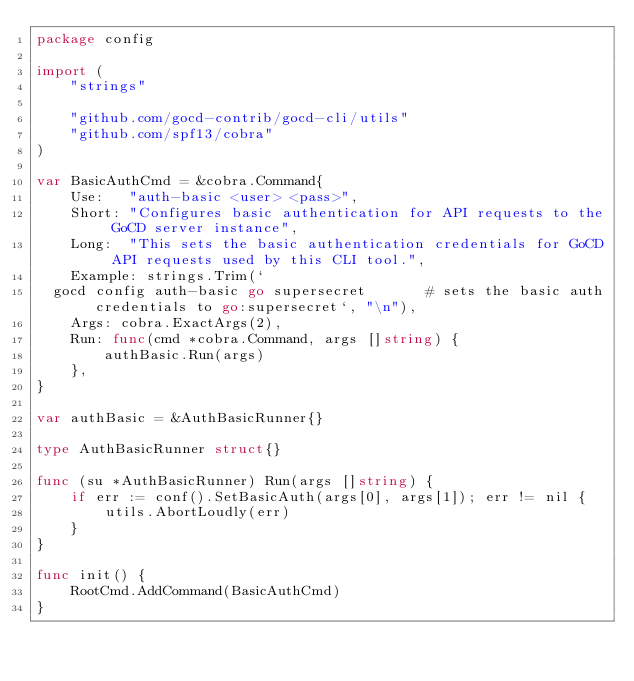<code> <loc_0><loc_0><loc_500><loc_500><_Go_>package config

import (
	"strings"

	"github.com/gocd-contrib/gocd-cli/utils"
	"github.com/spf13/cobra"
)

var BasicAuthCmd = &cobra.Command{
	Use:   "auth-basic <user> <pass>",
	Short: "Configures basic authentication for API requests to the GoCD server instance",
	Long:  "This sets the basic authentication credentials for GoCD API requests used by this CLI tool.",
	Example: strings.Trim(`
  gocd config auth-basic go supersecret       # sets the basic auth credentials to go:supersecret`, "\n"),
	Args: cobra.ExactArgs(2),
	Run: func(cmd *cobra.Command, args []string) {
		authBasic.Run(args)
	},
}

var authBasic = &AuthBasicRunner{}

type AuthBasicRunner struct{}

func (su *AuthBasicRunner) Run(args []string) {
	if err := conf().SetBasicAuth(args[0], args[1]); err != nil {
		utils.AbortLoudly(err)
	}
}

func init() {
	RootCmd.AddCommand(BasicAuthCmd)
}
</code> 